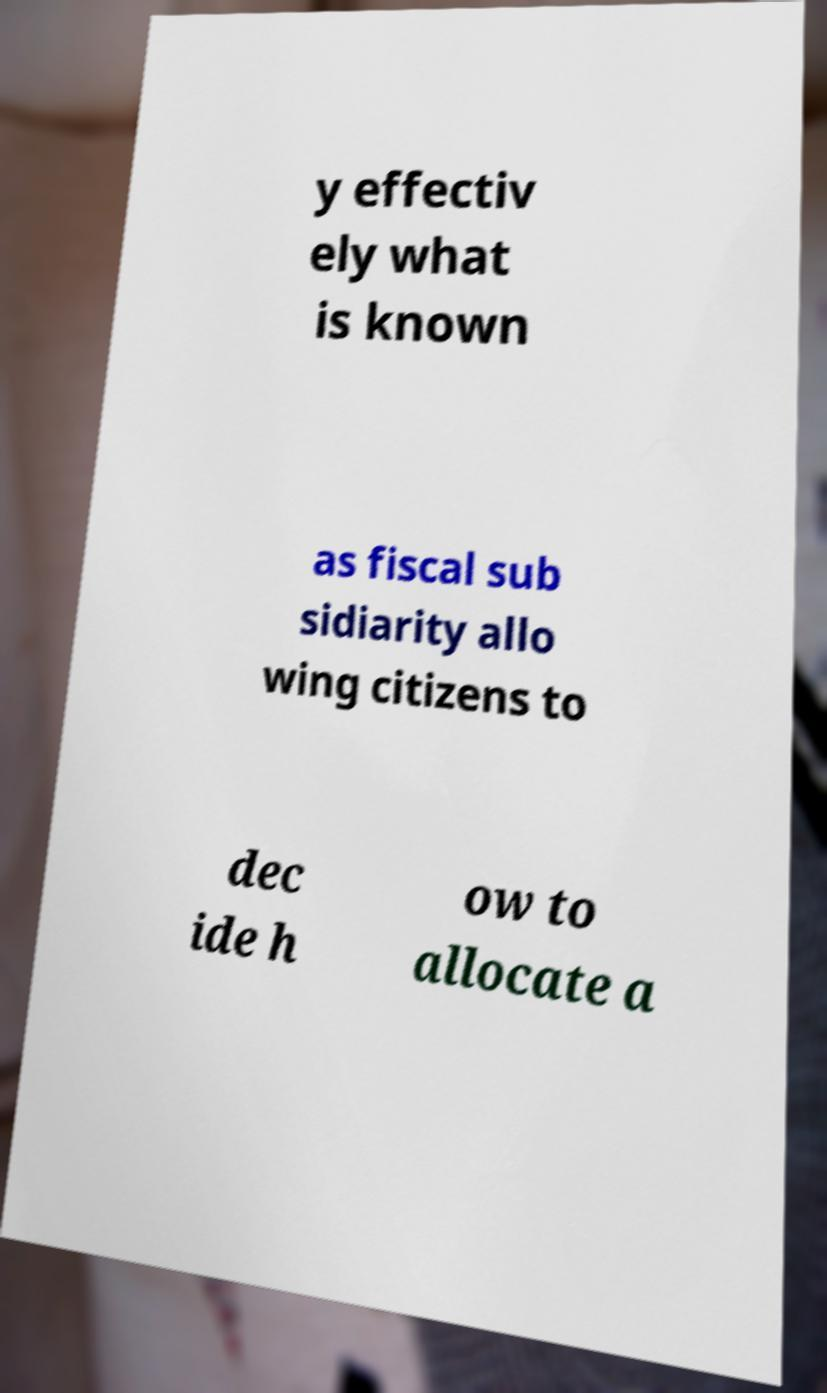Please identify and transcribe the text found in this image. y effectiv ely what is known as fiscal sub sidiarity allo wing citizens to dec ide h ow to allocate a 